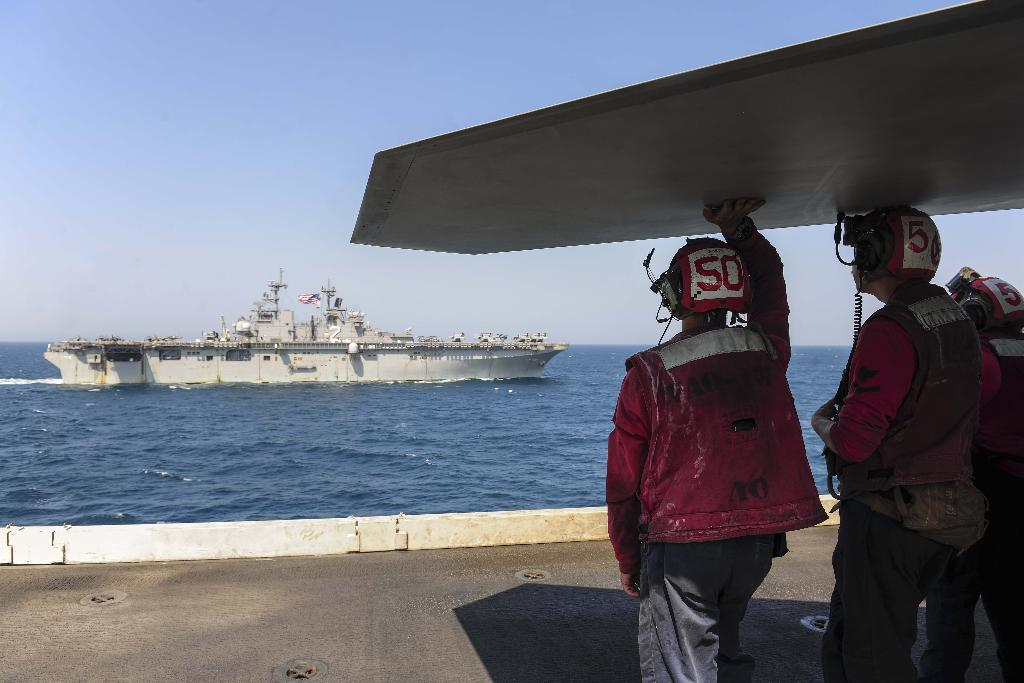<image>
Present a compact description of the photo's key features. Three people wearing number 50 helmets observe a boat. 